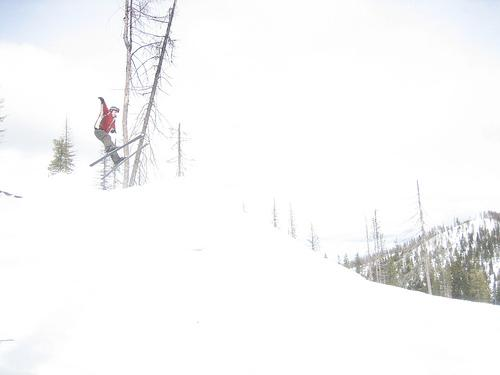Question: what is on the ground?
Choices:
A. Grass.
B. Glitter.
C. Candy.
D. Snow.
Answer with the letter. Answer: D Question: what is this person doing?
Choices:
A. Skiing.
B. Sewing.
C. Judging.
D. Scuba diving.
Answer with the letter. Answer: A Question: what color jacket is this person wearing?
Choices:
A. Blue.
B. Yellow.
C. Green.
D. Red.
Answer with the letter. Answer: D Question: what is the person doing with their arms?
Choices:
A. Crossing them.
B. Flailing them.
C. Holding them straight out.
D. Folding their hands.
Answer with the letter. Answer: C Question: what color pants is this person wearing?
Choices:
A. Gray.
B. Black.
C. Brown.
D. Beige.
Answer with the letter. Answer: A 